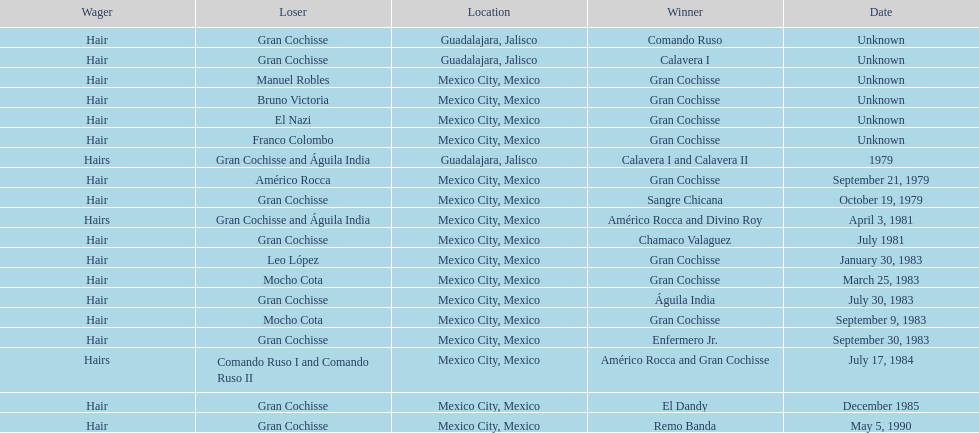How many games more than chamaco valaguez did sangre chicana win? 0. 